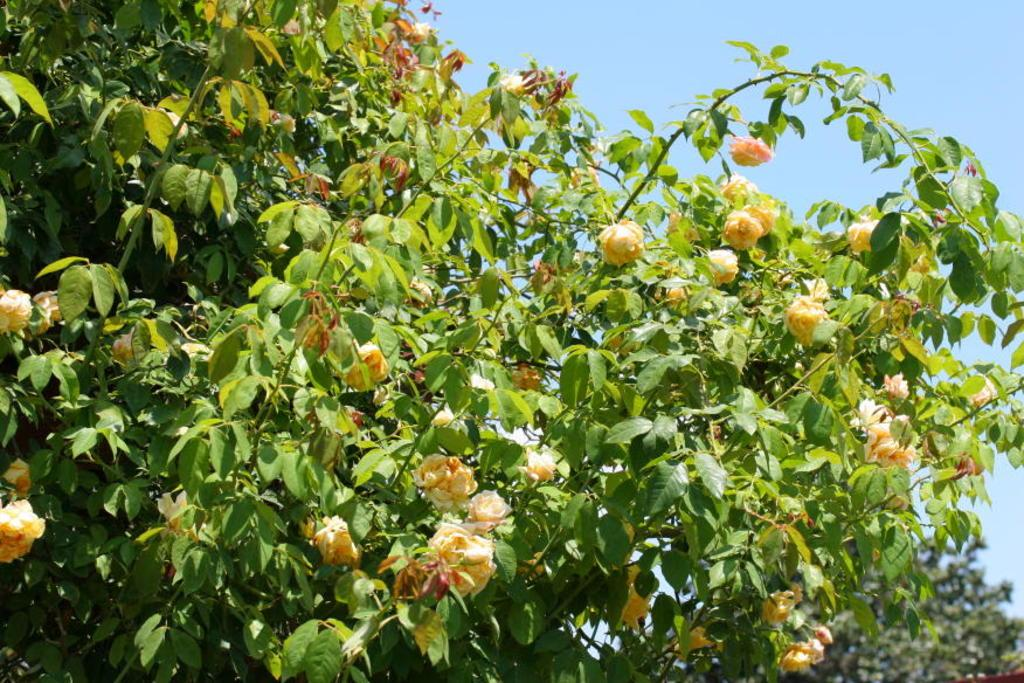What type of living organism can be seen in the image? There is a plant in the image. What specific feature of the plant is noteworthy? The plant has many flowers. What is visible at the top of the image? The sky is visible at the top of the image. What color is the spot in the middle of the plant? There is no spot in the middle of the plant, as the image only shows a plant with many flowers. 